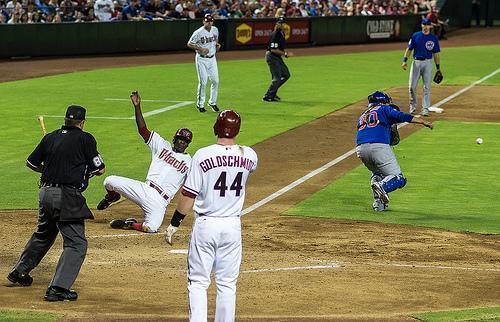How many umpires are in image?
Give a very brief answer. 2. 